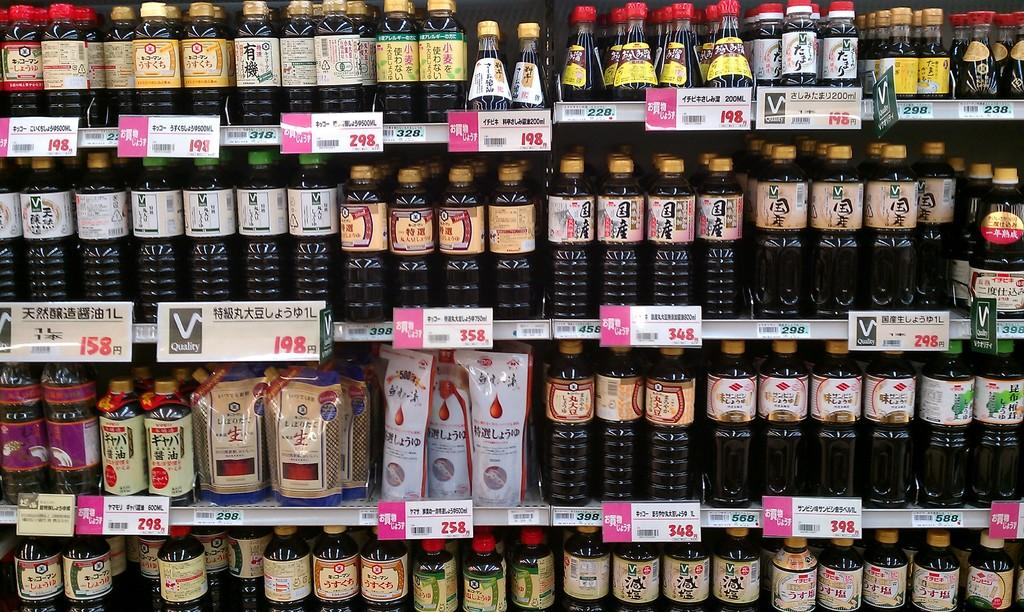<image>
Offer a succinct explanation of the picture presented. a grocery store advertises V Quality products on its shelf 